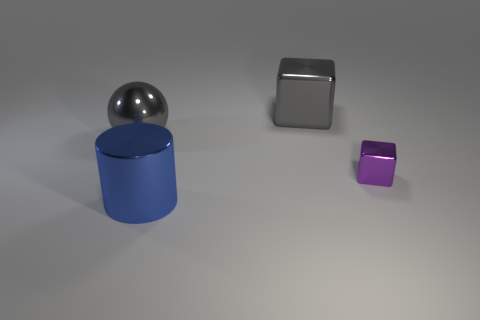Is there any other thing that is the same size as the metal cylinder?
Provide a succinct answer. Yes. How many cubes are tiny gray objects or tiny purple metal things?
Give a very brief answer. 1. What number of things are metallic objects to the left of the purple shiny cube or tiny gray rubber objects?
Make the answer very short. 3. What is the shape of the purple metal object that is in front of the large gray object that is on the left side of the gray metallic thing that is behind the big gray sphere?
Offer a terse response. Cube. What number of other objects have the same shape as the tiny purple shiny object?
Offer a terse response. 1. There is a big cube that is the same color as the large metal sphere; what is its material?
Offer a very short reply. Metal. There is a metal cube left of the block in front of the gray metal block; what number of large metallic things are behind it?
Ensure brevity in your answer.  0. Are there any other gray spheres made of the same material as the big gray sphere?
Keep it short and to the point. No. There is a cube that is the same color as the large metallic ball; what size is it?
Make the answer very short. Large. Are there fewer small spheres than large gray objects?
Offer a terse response. Yes. 